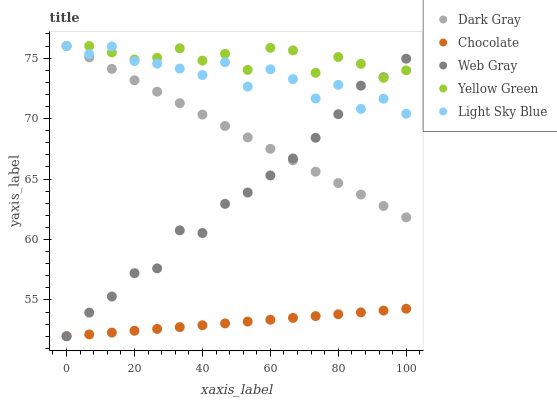Does Chocolate have the minimum area under the curve?
Answer yes or no. Yes. Does Yellow Green have the maximum area under the curve?
Answer yes or no. Yes. Does Web Gray have the minimum area under the curve?
Answer yes or no. No. Does Web Gray have the maximum area under the curve?
Answer yes or no. No. Is Chocolate the smoothest?
Answer yes or no. Yes. Is Light Sky Blue the roughest?
Answer yes or no. Yes. Is Web Gray the smoothest?
Answer yes or no. No. Is Web Gray the roughest?
Answer yes or no. No. Does Web Gray have the lowest value?
Answer yes or no. Yes. Does Yellow Green have the lowest value?
Answer yes or no. No. Does Light Sky Blue have the highest value?
Answer yes or no. Yes. Does Web Gray have the highest value?
Answer yes or no. No. Is Chocolate less than Light Sky Blue?
Answer yes or no. Yes. Is Yellow Green greater than Chocolate?
Answer yes or no. Yes. Does Yellow Green intersect Dark Gray?
Answer yes or no. Yes. Is Yellow Green less than Dark Gray?
Answer yes or no. No. Is Yellow Green greater than Dark Gray?
Answer yes or no. No. Does Chocolate intersect Light Sky Blue?
Answer yes or no. No. 